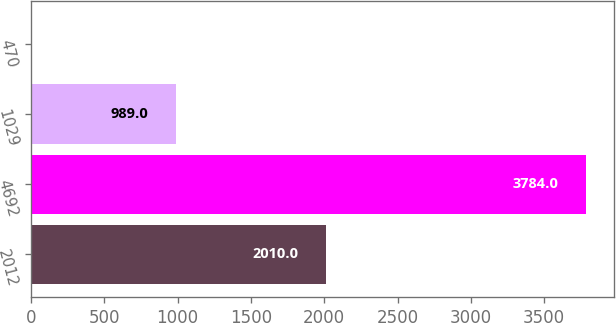Convert chart. <chart><loc_0><loc_0><loc_500><loc_500><bar_chart><fcel>2012<fcel>4692<fcel>1029<fcel>470<nl><fcel>2010<fcel>3784<fcel>989<fcel>3.84<nl></chart> 